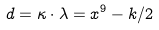Convert formula to latex. <formula><loc_0><loc_0><loc_500><loc_500>d = \kappa \cdot \lambda = x ^ { 9 } - k / 2</formula> 